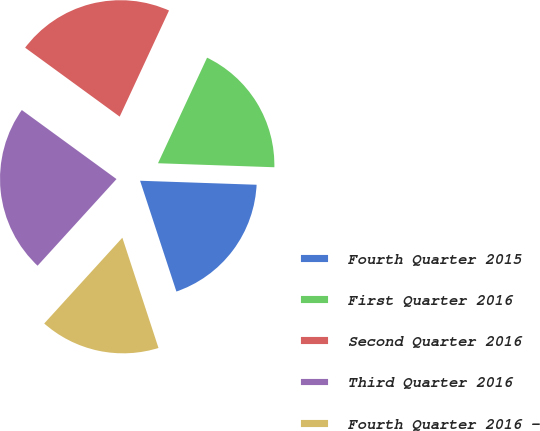<chart> <loc_0><loc_0><loc_500><loc_500><pie_chart><fcel>Fourth Quarter 2015<fcel>First Quarter 2016<fcel>Second Quarter 2016<fcel>Third Quarter 2016<fcel>Fourth Quarter 2016 -<nl><fcel>19.41%<fcel>18.62%<fcel>21.9%<fcel>23.27%<fcel>16.8%<nl></chart> 